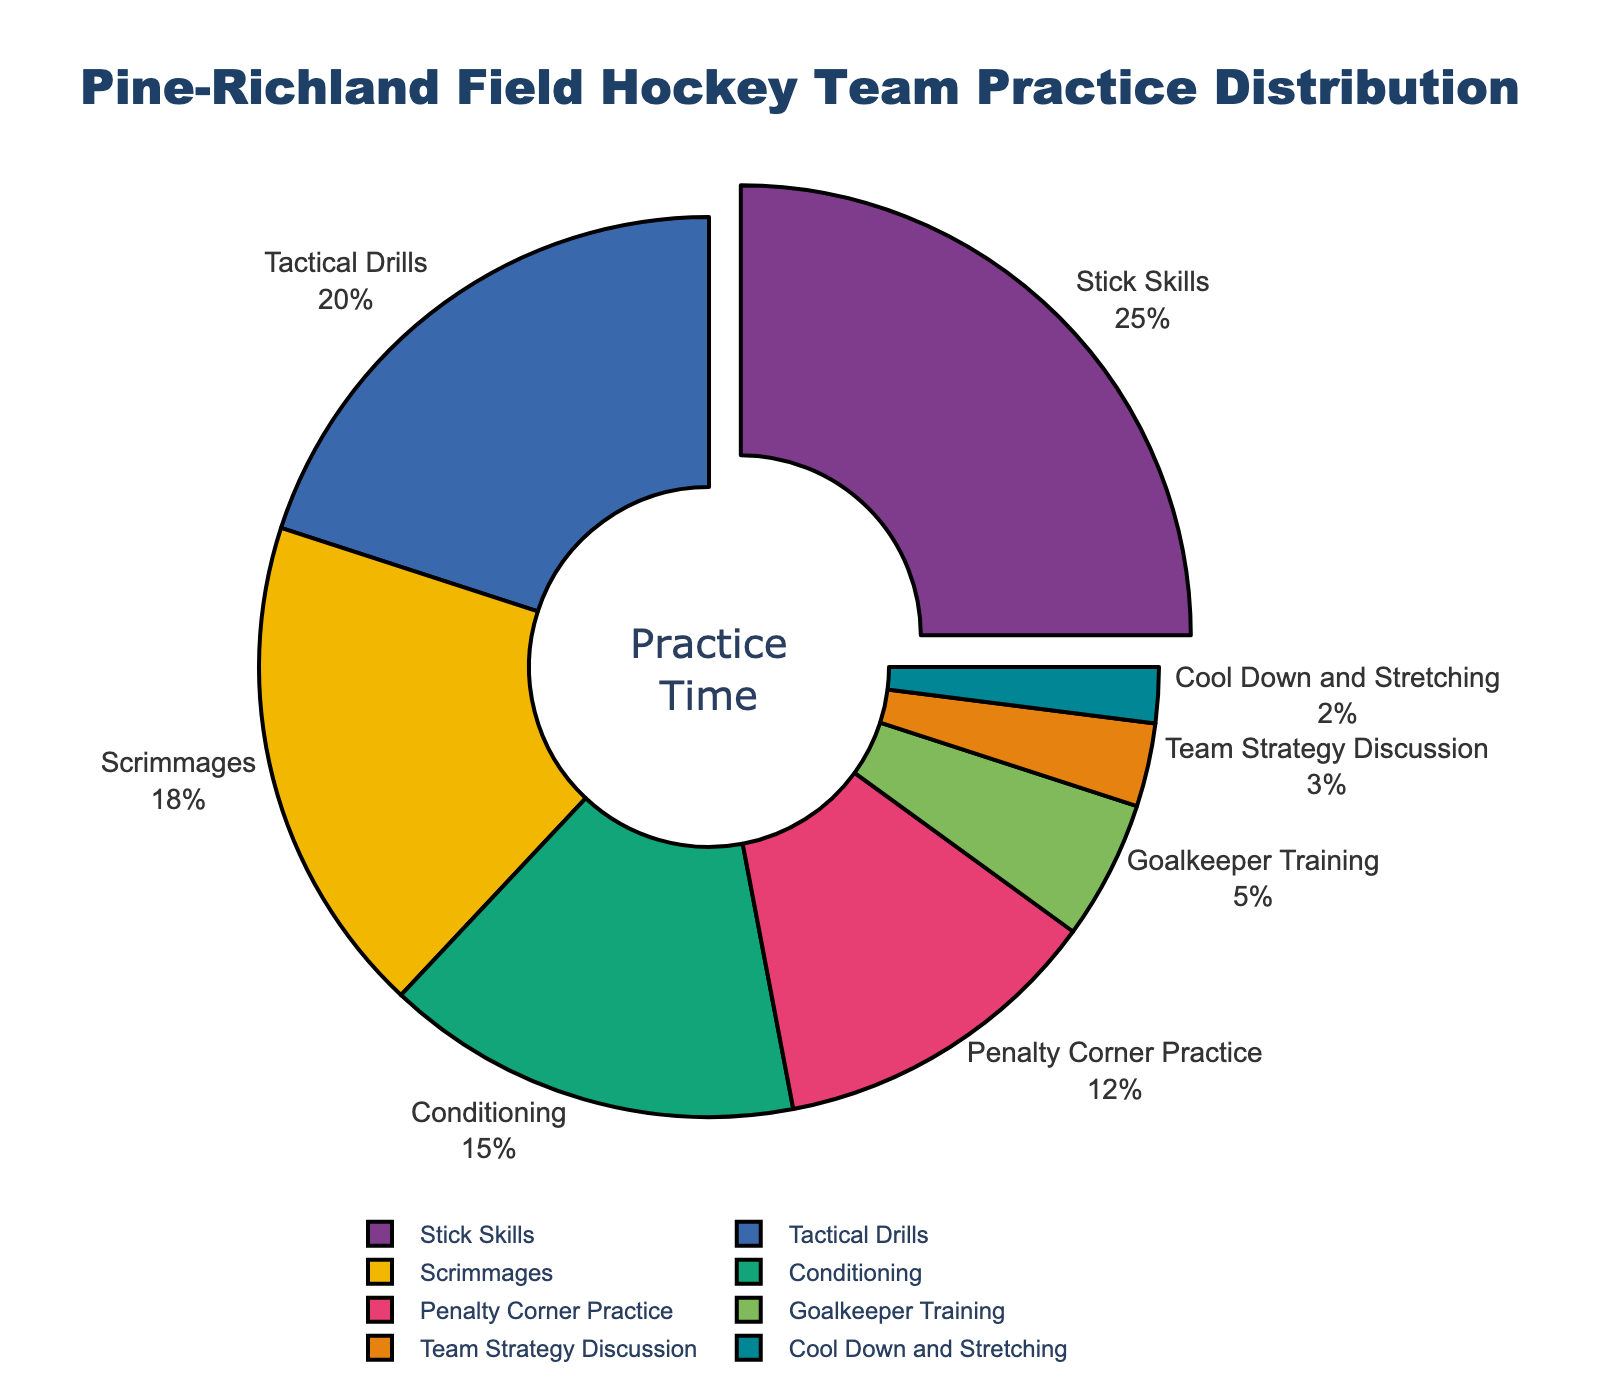What percentage of practice time is devoted to Stick Skills and Tactical Drills combined? To find the combined percentage, add the percentages of Stick Skills and Tactical Drills: 25% + 20% = 45%
Answer: 45% Which skill area takes up more practice time, Conditioning or Scrimmages? Compare the percentages for Conditioning (15%) and Scrimmages (18%). Since 18% is greater than 15%, more time is devoted to Scrimmages.
Answer: Scrimmages How much more practice time is dedicated to Penalty Corner Practice compared to Goalkeeper Training? Subtract the percentage for Goalkeeper Training (5%) from that of Penalty Corner Practice (12%): 12% - 5% = 7%
Answer: 7% Which skill area is allocated the least amount of practice time? The pie chart indicates the smallest segment is for Cool Down and Stretching at 2%.
Answer: Cool Down and Stretching Is more time spent on Tactical Drills or Penalty Corner Practice? Compare the percentages for Tactical Drills (20%) and Penalty Corner Practice (12%). Since 20% is greater than 12%, more time is spent on Tactical Drills.
Answer: Tactical Drills What percentage of practice time is spent on activities other than Stick Skills? Subtract the percentage of Stick Skills (25%) from 100%: 100% - 25% = 75%
Answer: 75% Are the cumulative practice times for Team Strategy Discussion, Cool Down and Stretching, and Goalkeeper Training more than the time dedicated to Scrimmages? Add the percentages for Team Strategy Discussion (3%), Cool Down and Stretching (2%), and Goalkeeper Training (5%): 3% + 2% + 5% = 10%. Since 10% is less than the Scrimmages percentage (18%), the cumulative time is not more.
Answer: No Does Scrimmages or Penalty Corner Practice make up a larger portion of the practice time? Compare the percentages of Scrimmages (18%) and Penalty Corner Practice (12%). Since 18% is greater than 12%, Scrimmages makes up a larger portion of practice time.
Answer: Scrimmages Which skill area represents exactly one-quarter of the practice time? The pie chart indicates that Stick Skills take up 25%, which is exactly one-quarter of the practice time.
Answer: Stick Skills 